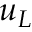<formula> <loc_0><loc_0><loc_500><loc_500>u _ { L }</formula> 